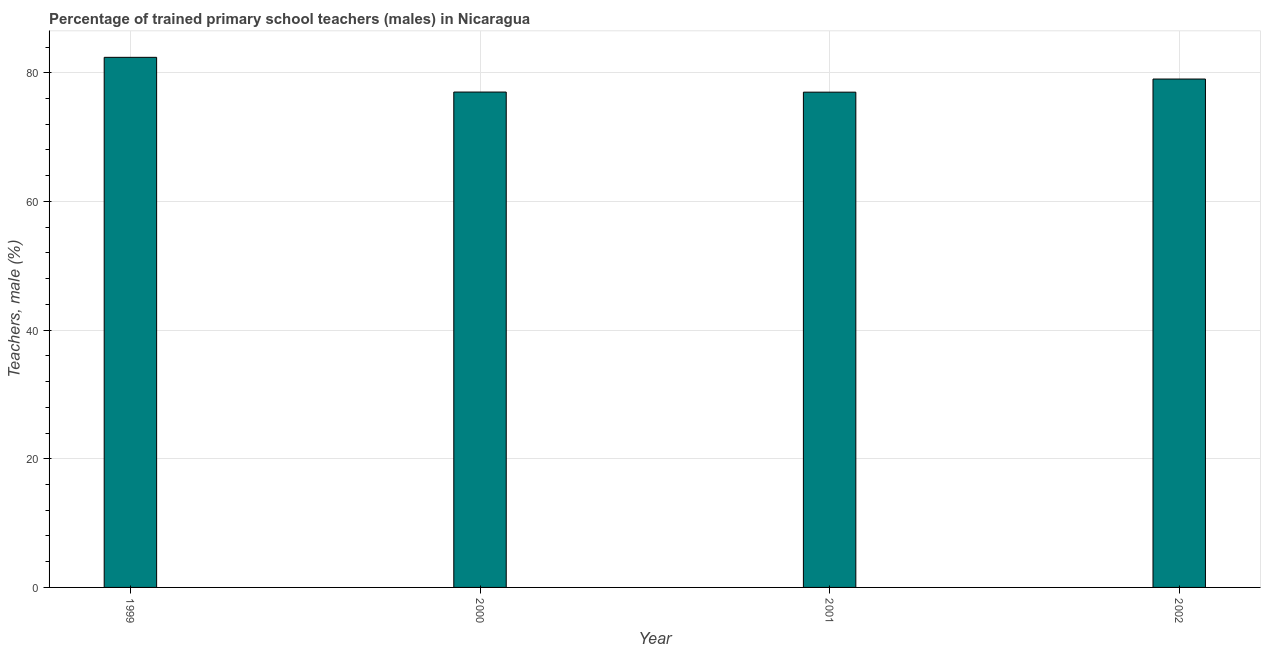Does the graph contain any zero values?
Provide a short and direct response. No. Does the graph contain grids?
Your answer should be very brief. Yes. What is the title of the graph?
Offer a very short reply. Percentage of trained primary school teachers (males) in Nicaragua. What is the label or title of the X-axis?
Offer a terse response. Year. What is the label or title of the Y-axis?
Provide a succinct answer. Teachers, male (%). What is the percentage of trained male teachers in 2001?
Give a very brief answer. 76.98. Across all years, what is the maximum percentage of trained male teachers?
Provide a succinct answer. 82.4. Across all years, what is the minimum percentage of trained male teachers?
Keep it short and to the point. 76.98. What is the sum of the percentage of trained male teachers?
Ensure brevity in your answer.  315.4. What is the difference between the percentage of trained male teachers in 2000 and 2001?
Provide a short and direct response. 0.02. What is the average percentage of trained male teachers per year?
Your response must be concise. 78.85. What is the median percentage of trained male teachers?
Your answer should be compact. 78.01. Do a majority of the years between 2002 and 2000 (inclusive) have percentage of trained male teachers greater than 24 %?
Ensure brevity in your answer.  Yes. What is the ratio of the percentage of trained male teachers in 1999 to that in 2001?
Provide a short and direct response. 1.07. Is the percentage of trained male teachers in 1999 less than that in 2002?
Keep it short and to the point. No. What is the difference between the highest and the second highest percentage of trained male teachers?
Offer a very short reply. 3.37. What is the difference between the highest and the lowest percentage of trained male teachers?
Provide a short and direct response. 5.41. How many bars are there?
Your answer should be very brief. 4. What is the Teachers, male (%) of 1999?
Give a very brief answer. 82.4. What is the Teachers, male (%) in 2000?
Provide a succinct answer. 77. What is the Teachers, male (%) of 2001?
Provide a short and direct response. 76.98. What is the Teachers, male (%) of 2002?
Offer a terse response. 79.02. What is the difference between the Teachers, male (%) in 1999 and 2000?
Ensure brevity in your answer.  5.4. What is the difference between the Teachers, male (%) in 1999 and 2001?
Provide a succinct answer. 5.41. What is the difference between the Teachers, male (%) in 1999 and 2002?
Your answer should be very brief. 3.37. What is the difference between the Teachers, male (%) in 2000 and 2001?
Ensure brevity in your answer.  0.02. What is the difference between the Teachers, male (%) in 2000 and 2002?
Your answer should be very brief. -2.02. What is the difference between the Teachers, male (%) in 2001 and 2002?
Give a very brief answer. -2.04. What is the ratio of the Teachers, male (%) in 1999 to that in 2000?
Provide a succinct answer. 1.07. What is the ratio of the Teachers, male (%) in 1999 to that in 2001?
Your answer should be very brief. 1.07. What is the ratio of the Teachers, male (%) in 1999 to that in 2002?
Provide a succinct answer. 1.04. What is the ratio of the Teachers, male (%) in 2000 to that in 2002?
Your answer should be compact. 0.97. 